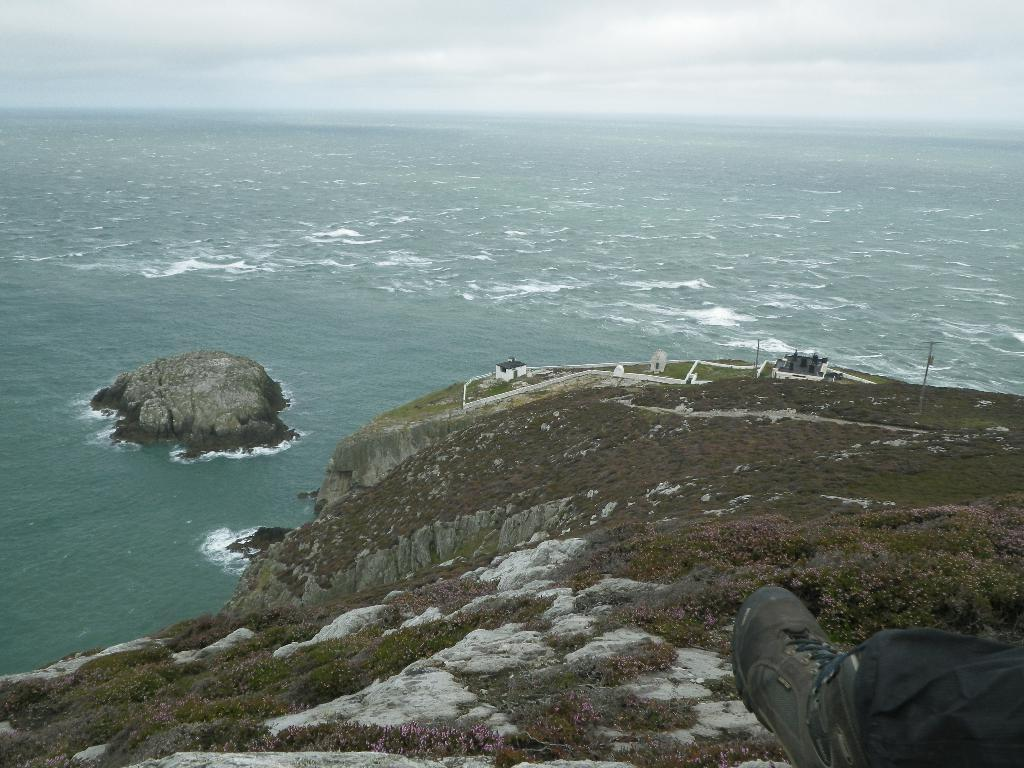What can be seen in the sky in the image? Clouds are visible in the image. What is the main feature of the landscape in the image? Hills are present in the image. What type of terrain is visible in the image? Grass is visible in the image. What structures are present in the image? Buildings are present in the image. What objects are in the water in the image? Poles are in the water in the image. Is there any personal item visible in the image? Yes, there is one shoe in the image. Can you see a volleyball being played in the image? No, there is no volleyball or any indication of a game being played in the image. What type of bird is flying over the hills in the image? There are no birds visible in the image. What kind of apparatus is being used by the people in the image? There are no people or any apparatus present in the image. 